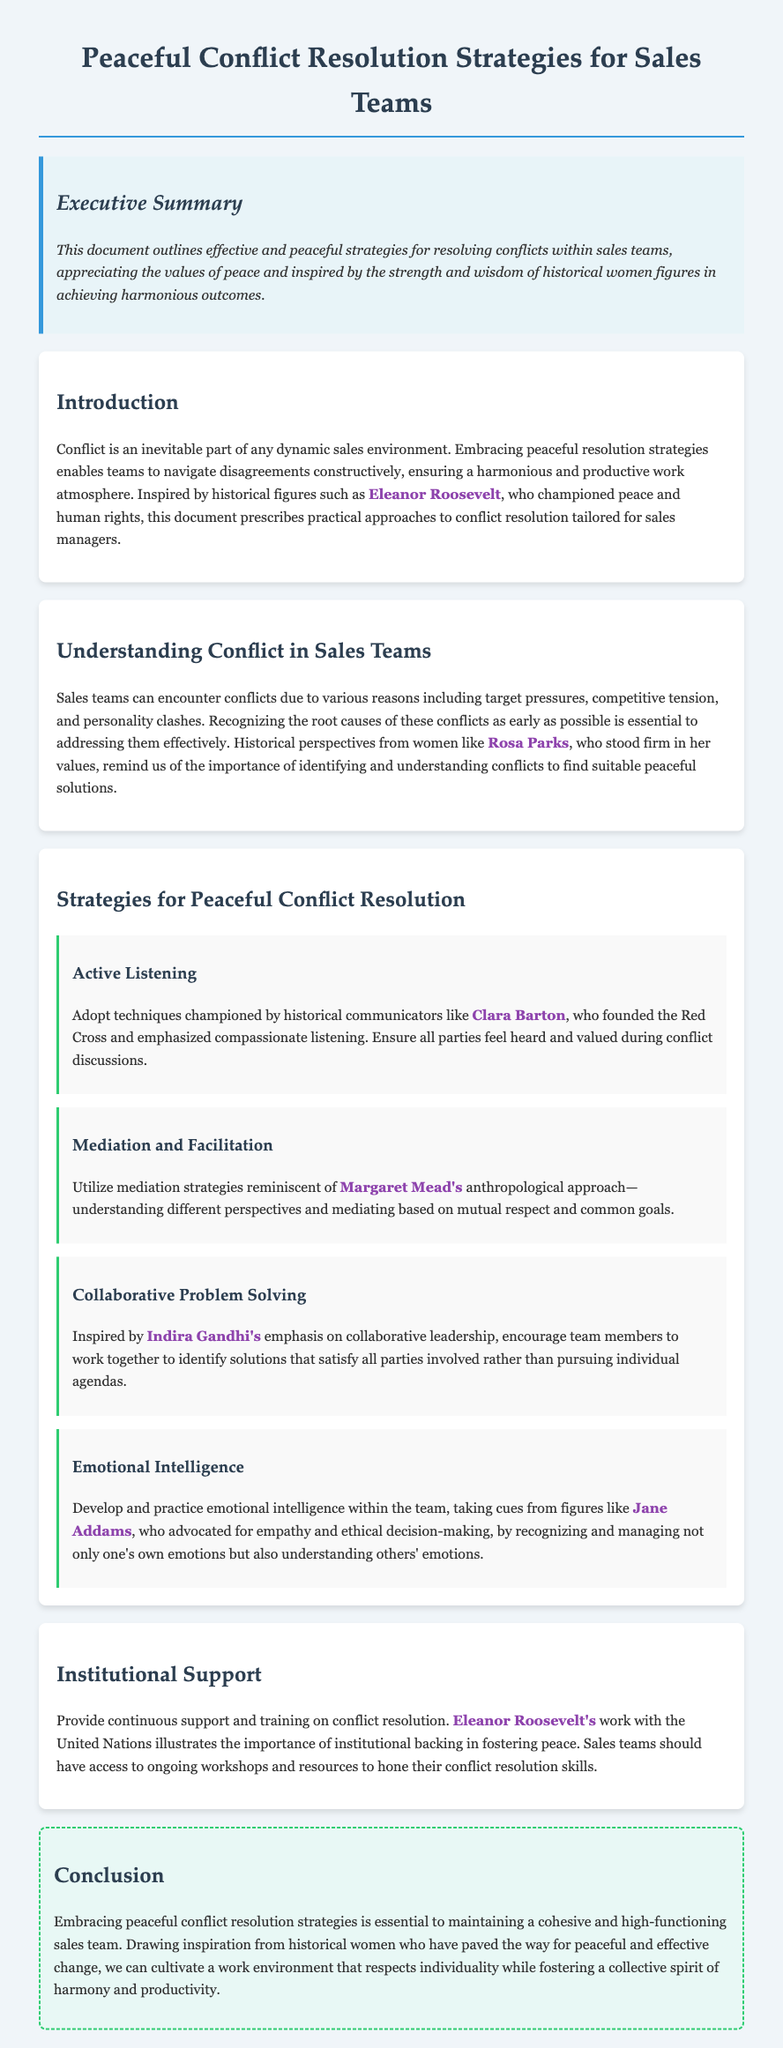What is the title of the document? The title of the document is presented at the top of the rendered page as the main heading.
Answer: Peaceful Conflict Resolution Strategies for Sales Teams Who is a historical figure mentioned in the introduction? The introduction highlights historical figures who inspired peaceful resolution strategies, and one of them is specifically named.
Answer: Eleanor Roosevelt What strategy is described under "Active Listening"? The subsection presents the key strategy for conflict resolution in a sales environment with an emphasis on listening.
Answer: Compassionate listening Which historical figure is associated with mediation strategies? The document refers to a particular figure related to the approach of mediation in conflict resolution efforts.
Answer: Margaret Mead What does the document suggest for continuous support in conflict resolution? The institutional support section details the need for ongoing resources and training, which is emphasized through an example.
Answer: Workshops and resources What is emphasized in the section on Emotional Intelligence? This section focuses on a specific aspect of emotional intelligence and points to the importance of empathy in conflict resolution.
Answer: Empathy and ethical decision-making What does the conclusion state about peaceful conflict resolution strategies? The conclusion summarizes the overall message of the document regarding team cohesion and conflict resolution.
Answer: Essential to maintaining a cohesive team How many strategies for peaceful conflict resolution are presented? The document outlines various strategies, and the number is specified in the relevant section.
Answer: Four strategies 